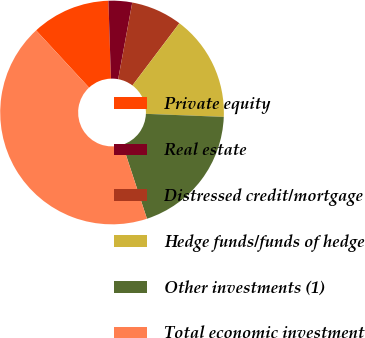Convert chart to OTSL. <chart><loc_0><loc_0><loc_500><loc_500><pie_chart><fcel>Private equity<fcel>Real estate<fcel>Distressed credit/mortgage<fcel>Hedge funds/funds of hedge<fcel>Other investments (1)<fcel>Total economic investment<nl><fcel>11.36%<fcel>3.41%<fcel>7.39%<fcel>15.34%<fcel>19.32%<fcel>43.18%<nl></chart> 